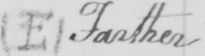What text is written in this handwritten line? (E) Farther 